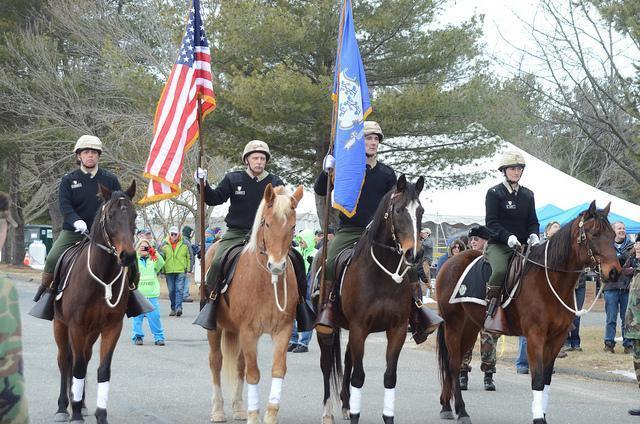How many people are there?
Give a very brief answer. 7. How many horses are in the picture?
Give a very brief answer. 4. How many knives are visible in the picture?
Give a very brief answer. 0. 